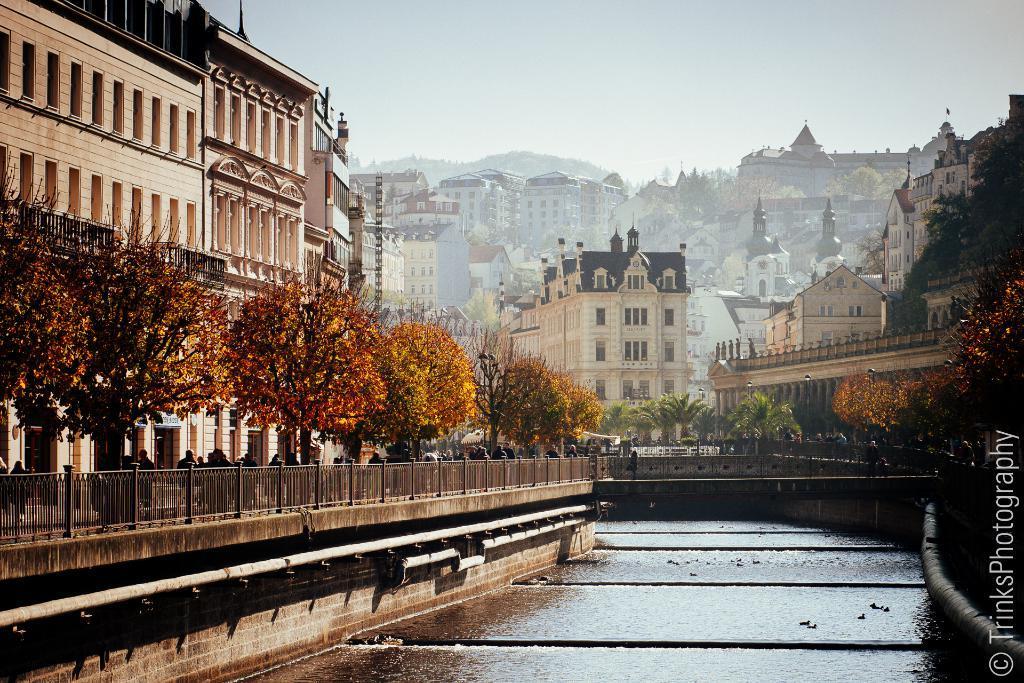Could you give a brief overview of what you see in this image? In this picture, on the right side, we can see some buildings, windows, trees, plants. On the left side, we can also see a bridge and group of people are walking on the bridge, trees, plants, buildings. In the background, there are some buildings, windows, trees and a bridge. On the top there is a sky. 